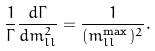Convert formula to latex. <formula><loc_0><loc_0><loc_500><loc_500>\frac { 1 } { \Gamma } \frac { d \Gamma } { d m _ { l l } ^ { 2 } } = \frac { 1 } { ( m _ { l l } ^ { \max } ) ^ { 2 } } .</formula> 